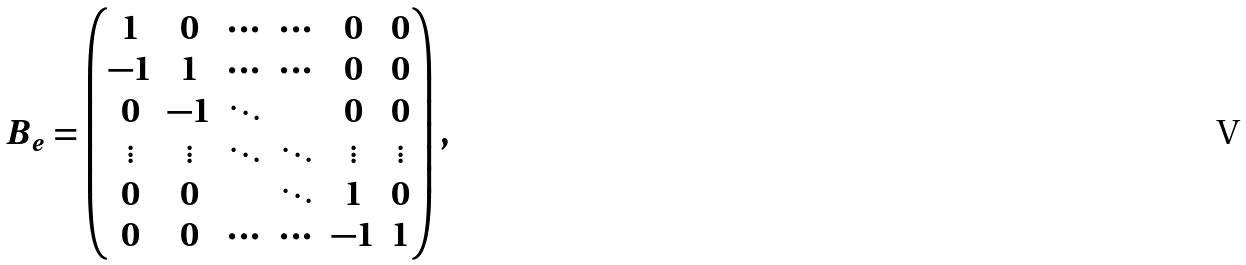<formula> <loc_0><loc_0><loc_500><loc_500>B _ { e } = \begin{pmatrix} 1 & 0 & \cdots & \cdots & 0 & 0 \\ - 1 & 1 & \cdots & \cdots & 0 & 0 \\ 0 & - 1 & \ddots & & 0 & 0 \\ \vdots & \vdots & \ddots & \ddots & \vdots & \vdots \\ 0 & 0 & & \ddots & 1 & 0 \\ 0 & 0 & \cdots & \cdots & - 1 & 1 \end{pmatrix} ,</formula> 